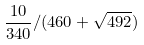Convert formula to latex. <formula><loc_0><loc_0><loc_500><loc_500>\frac { 1 0 } { 3 4 0 } / ( 4 6 0 + \sqrt { 4 9 2 } )</formula> 